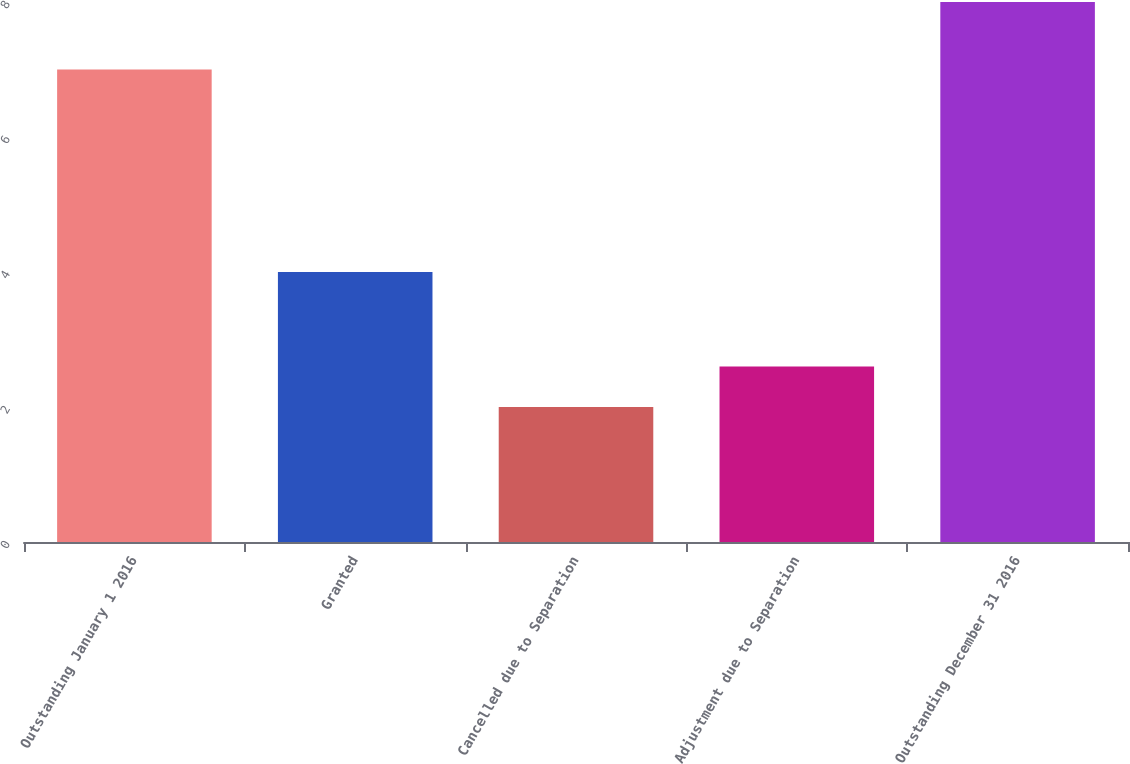<chart> <loc_0><loc_0><loc_500><loc_500><bar_chart><fcel>Outstanding January 1 2016<fcel>Granted<fcel>Cancelled due to Separation<fcel>Adjustment due to Separation<fcel>Outstanding December 31 2016<nl><fcel>7<fcel>4<fcel>2<fcel>2.6<fcel>8<nl></chart> 